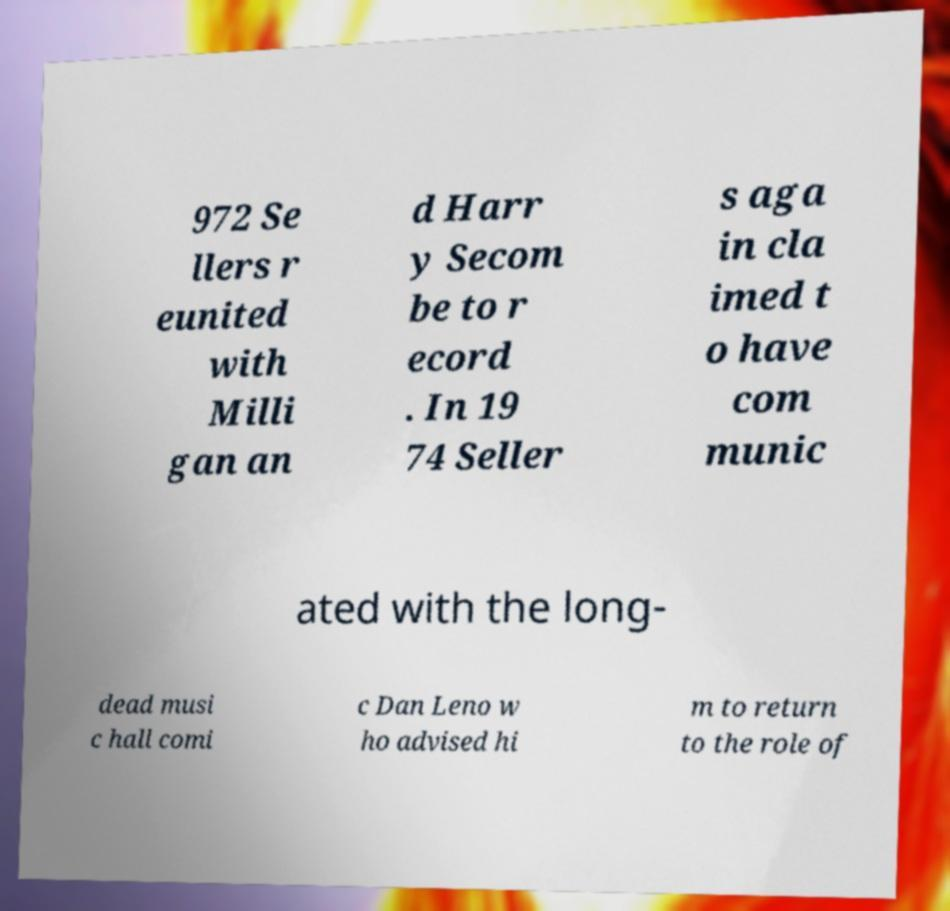Could you assist in decoding the text presented in this image and type it out clearly? 972 Se llers r eunited with Milli gan an d Harr y Secom be to r ecord . In 19 74 Seller s aga in cla imed t o have com munic ated with the long- dead musi c hall comi c Dan Leno w ho advised hi m to return to the role of 